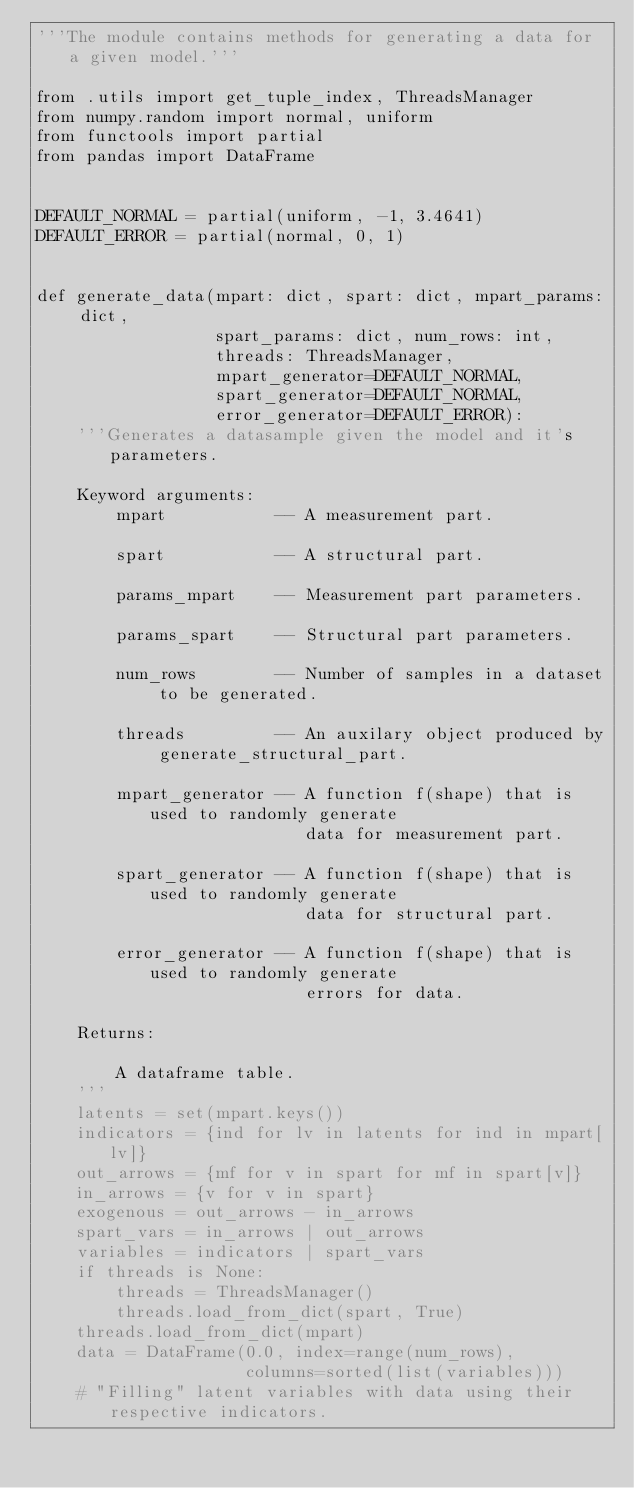Convert code to text. <code><loc_0><loc_0><loc_500><loc_500><_Python_>'''The module contains methods for generating a data for a given model.'''

from .utils import get_tuple_index, ThreadsManager
from numpy.random import normal, uniform
from functools import partial
from pandas import DataFrame


DEFAULT_NORMAL = partial(uniform, -1, 3.4641)
DEFAULT_ERROR = partial(normal, 0, 1)


def generate_data(mpart: dict, spart: dict, mpart_params: dict,
                  spart_params: dict, num_rows: int,
                  threads: ThreadsManager,
                  mpart_generator=DEFAULT_NORMAL,
                  spart_generator=DEFAULT_NORMAL,
                  error_generator=DEFAULT_ERROR):
    '''Generates a datasample given the model and it's parameters.
    
    Keyword arguments:
        mpart           -- A measurement part.
        
        spart           -- A structural part.
        
        params_mpart    -- Measurement part parameters.
        
        params_spart    -- Structural part parameters.
        
        num_rows        -- Number of samples in a dataset to be generated.
        
        threads         -- An auxilary object produced by generate_structural_part.
        
        mpart_generator -- A function f(shape) that is used to randomly generate
                           data for measurement part.
                           
        spart_generator -- A function f(shape) that is used to randomly generate
                           data for structural part.
                           
        error_generator -- A function f(shape) that is used to randomly generate
                           errors for data.
                           
    Returns:
        
        A dataframe table.
    '''
    latents = set(mpart.keys())
    indicators = {ind for lv in latents for ind in mpart[lv]}
    out_arrows = {mf for v in spart for mf in spart[v]}
    in_arrows = {v for v in spart}
    exogenous = out_arrows - in_arrows
    spart_vars = in_arrows | out_arrows
    variables = indicators | spart_vars
    if threads is None:
        threads = ThreadsManager()
        threads.load_from_dict(spart, True)
    threads.load_from_dict(mpart)
    data = DataFrame(0.0, index=range(num_rows),
                     columns=sorted(list(variables)))
    # "Filling" latent variables with data using their respective indicators.</code> 